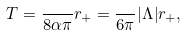<formula> <loc_0><loc_0><loc_500><loc_500>T = \frac { } { 8 \alpha \pi } r _ { + } = \frac { } { 6 \pi } | \Lambda | r _ { + } ,</formula> 